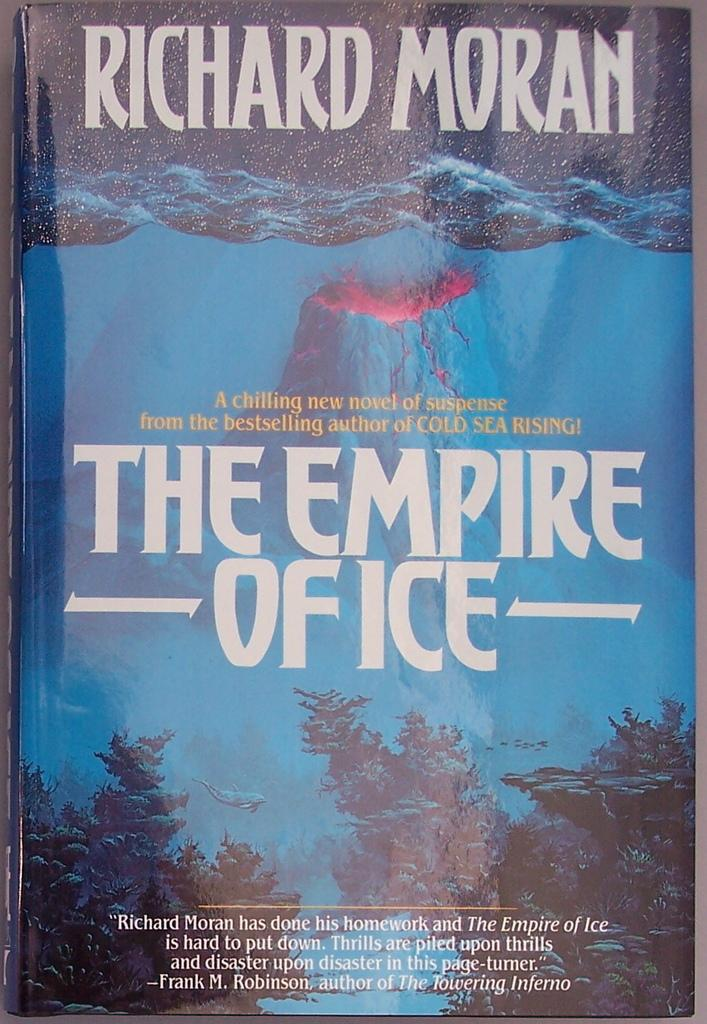<image>
Present a compact description of the photo's key features. A book by Richard Moran called "The Empire Office" has a volcano on the cover. 